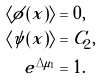<formula> <loc_0><loc_0><loc_500><loc_500>\langle \phi ( x ) \rangle & = 0 , \\ \langle \psi ( x ) \rangle & = C _ { 2 } , \\ e ^ { \Delta \mu _ { 1 } } & = 1 .</formula> 